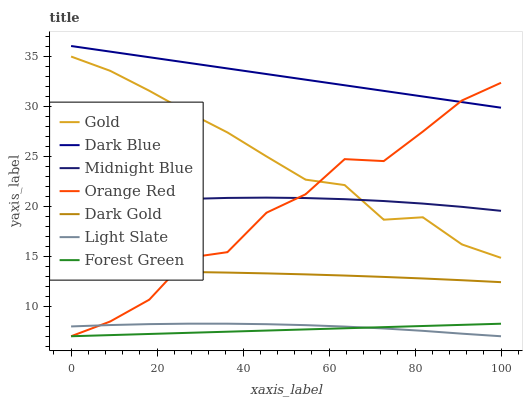Does Forest Green have the minimum area under the curve?
Answer yes or no. Yes. Does Dark Blue have the maximum area under the curve?
Answer yes or no. Yes. Does Gold have the minimum area under the curve?
Answer yes or no. No. Does Gold have the maximum area under the curve?
Answer yes or no. No. Is Forest Green the smoothest?
Answer yes or no. Yes. Is Orange Red the roughest?
Answer yes or no. Yes. Is Gold the smoothest?
Answer yes or no. No. Is Gold the roughest?
Answer yes or no. No. Does Light Slate have the lowest value?
Answer yes or no. Yes. Does Gold have the lowest value?
Answer yes or no. No. Does Dark Blue have the highest value?
Answer yes or no. Yes. Does Gold have the highest value?
Answer yes or no. No. Is Dark Gold less than Dark Blue?
Answer yes or no. Yes. Is Gold greater than Light Slate?
Answer yes or no. Yes. Does Forest Green intersect Light Slate?
Answer yes or no. Yes. Is Forest Green less than Light Slate?
Answer yes or no. No. Is Forest Green greater than Light Slate?
Answer yes or no. No. Does Dark Gold intersect Dark Blue?
Answer yes or no. No. 